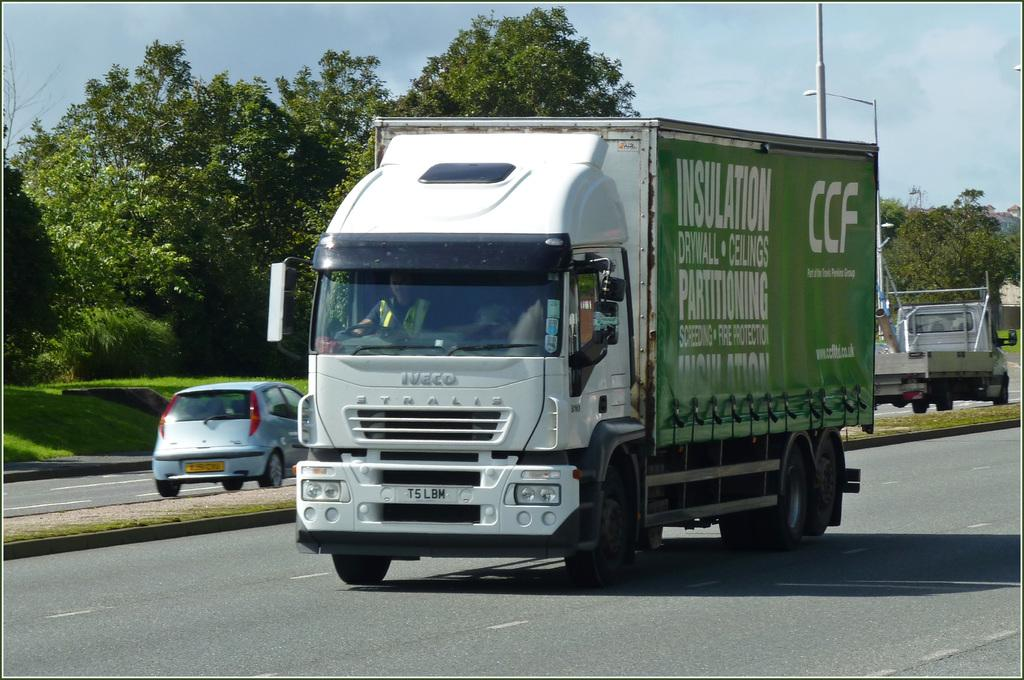What is happening on the road in the image? There are vehicles on the road in the image. Can you describe the person in the image? There is a person in the image. What can be seen in the background of the image? There are trees and the sky visible in the background of the image. What type of sack is being used for the coal discussion in the image? There is no sack or coal discussion present in the image. How many coal pieces are visible in the image? There are no coal pieces present in the image. 